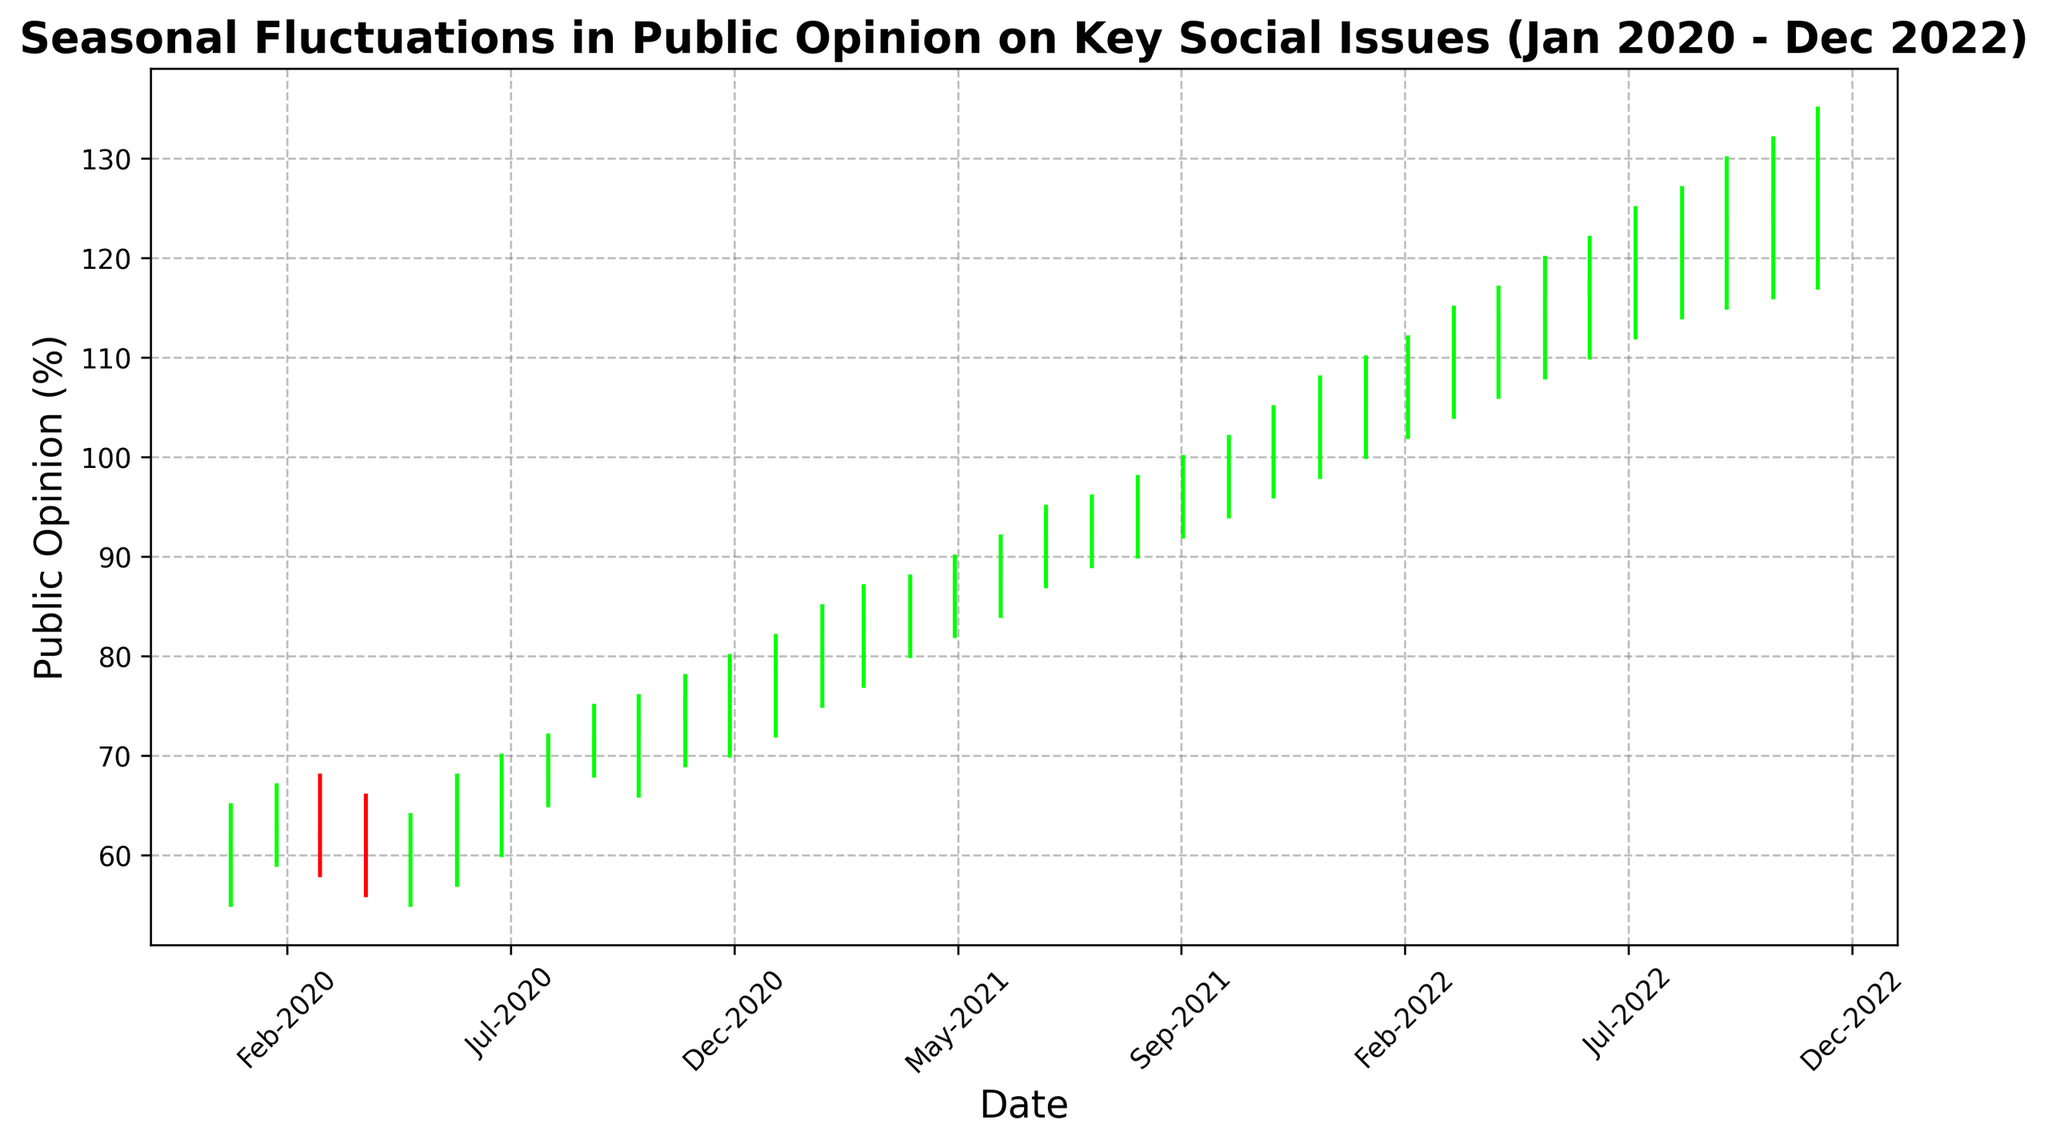When did the lowest "Close" value occur on the chart? From the figure, the lowest "Close" value can be identified by looking for the shortest final rectangle height. The lowest "Close" value occurs at "Apr-2020," which is marked at 60.
Answer: Apr-2020 During which month and year did the highest "High" value occur? The highest "High" value can be observed from the vertical line stretching to the maximum height on the chart. This peak value appears in "Dec-2022," reaching 135.
Answer: Dec-2022 What is the trend of the "Close" values from Jan 2020 to Dec 2022? To identify the trend, observe the overall direction of the final heights of the rectangles from left to right. The "Close" values generally show an increasing trend starting from 62 in Jan-2020 to 128 in Dec-2022.
Answer: Increasing Which month in 2021 had the smallest difference between "Open" and "Close" values? To determine the smallest difference between "Open" and "Close" values in 2021, visually compare the height of the rectangles. The smallest difference appears in "Apr-2021," where both "Open" and "Close" values are very close, with "Open" at 84 and "Close" at 86, giving a difference of 2.
Answer: Apr-2021 In which month of 2022 did the "Close" value rise above 110 for the first time? Observing the rectangles of "Close" values, the first instance where the "Close" value goes above 110 can be spotted in "May-2022," where the "Close" value is 114.
Answer: May-2022 How many months show a decline in "Close" value from the previous month? To determine the number of months showing a decline, count the occurrences where the final height of the rectangle is lower than the preceding month's rectangle. This occurs in "Mar-2020" (down from Feb-2020), "Apr-2020" (down from Mar-2020), and "Oct-2022" (down from Sep-2022). That makes 3 months.
Answer: 3 What is the average "Close" value of the first six months in the dataset? The first six months span from Jan-2020 to Jun-2020. Their "Close" values are: 62, 63, 61, 60, 62, and 65. Summing these up yields 373, and dividing by 6 gives an average of 62.17.
Answer: 62.17 By how much did the "High" value increase from Jan 2020 to Dec 2022? The "High" value in Jan-2020 is 65, and the "High" value in Dec-2022 is 135. Subtraction results in 135 - 65 = 70.
Answer: 70 Which month experienced the highest single-month increase in "Close" value, and what was that increase? Identify the highest single-month increase by calculating the difference between successive "Close" values and noting the highest change. This increase occurs from Nov-2020 (Close: 76) to Dec-2020 (Close: 78), with an increase of 2.
Answer: Dec-2020, 2 